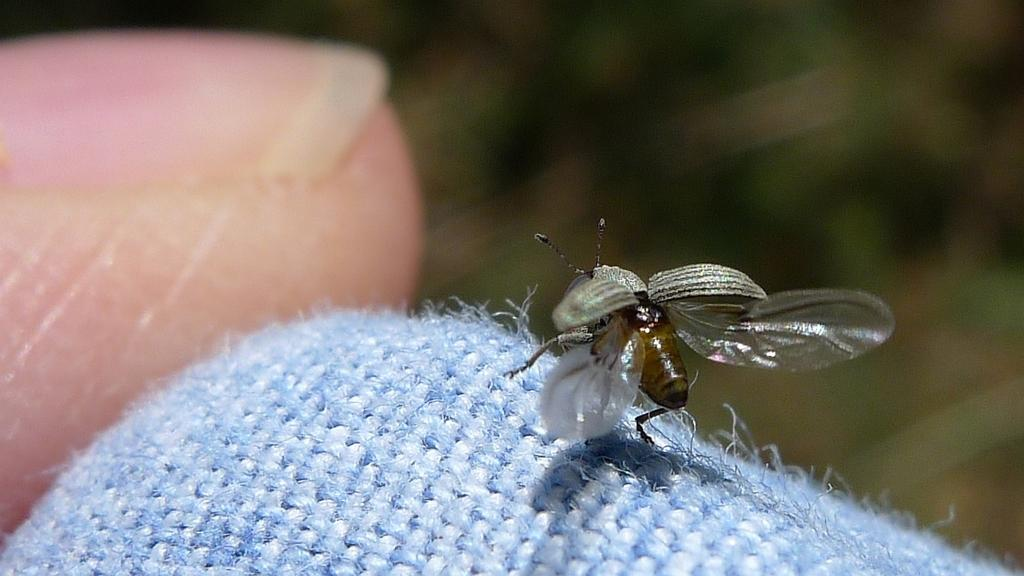What type of creature is present in the image? There is an insect in the image. What color is the insect? The insect is brown in color. What is the insect resting on? The insect is on a blue cloth. What part of a person can be seen in the image? A finger and the nail of a hand are visible in the image. How would you describe the background of the image? The background of the image is blurred. What type of bells are ringing in the image? There are no bells present in the image; it features an insect on a blue cloth with a finger and nail of a hand visible. 